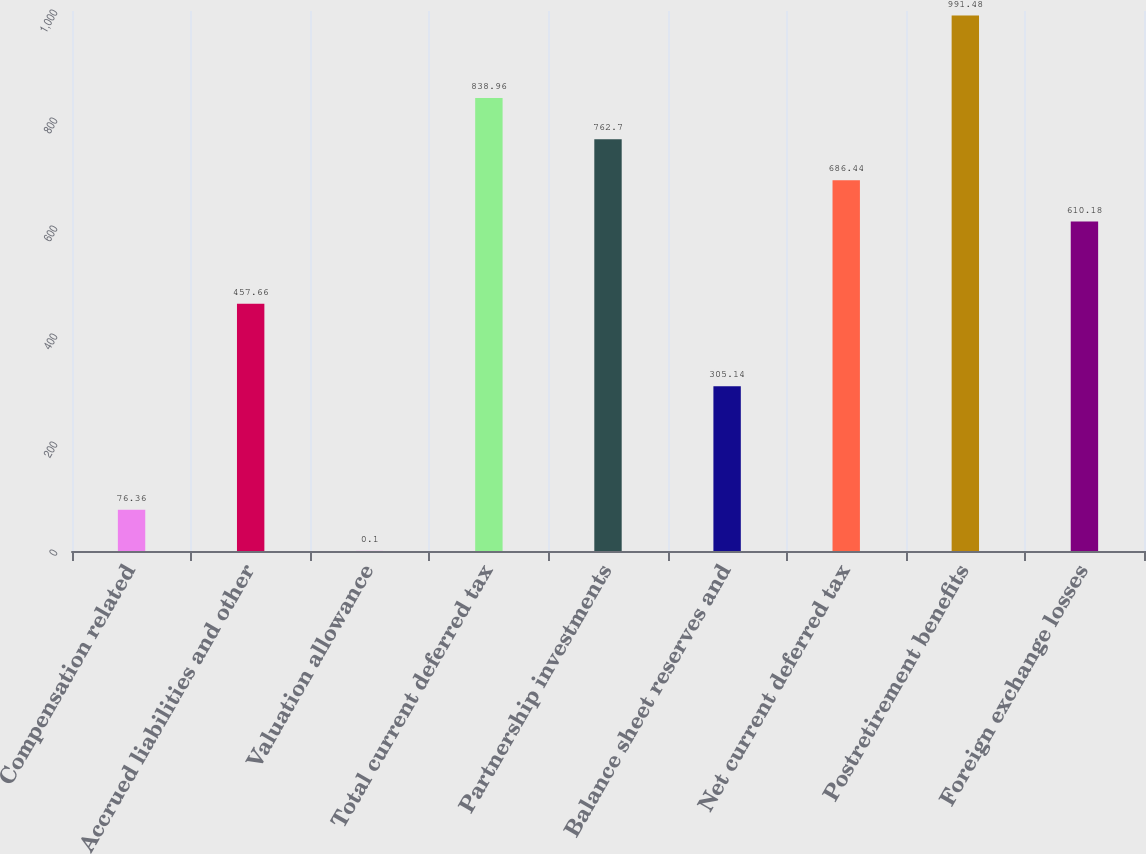Convert chart. <chart><loc_0><loc_0><loc_500><loc_500><bar_chart><fcel>Compensation related<fcel>Accrued liabilities and other<fcel>Valuation allowance<fcel>Total current deferred tax<fcel>Partnership investments<fcel>Balance sheet reserves and<fcel>Net current deferred tax<fcel>Postretirement benefits<fcel>Foreign exchange losses<nl><fcel>76.36<fcel>457.66<fcel>0.1<fcel>838.96<fcel>762.7<fcel>305.14<fcel>686.44<fcel>991.48<fcel>610.18<nl></chart> 